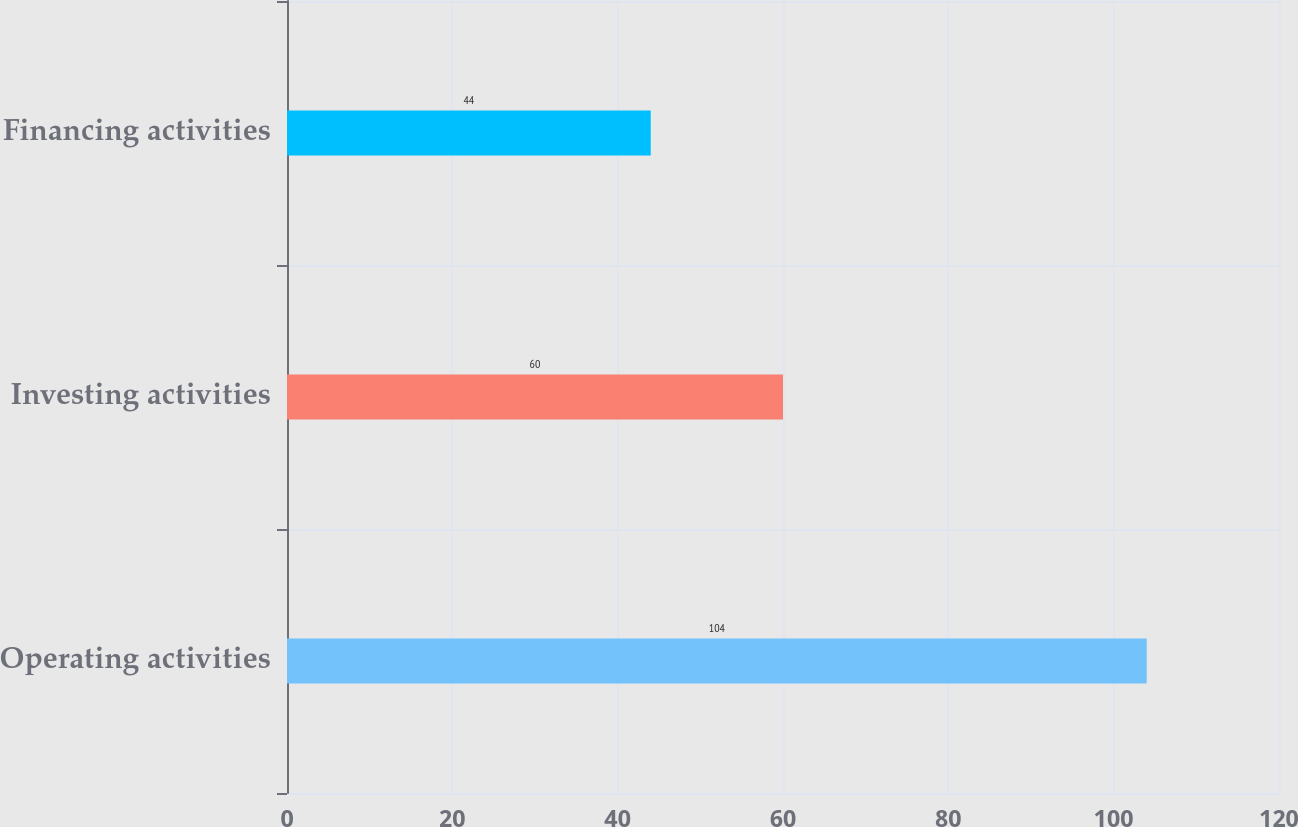Convert chart to OTSL. <chart><loc_0><loc_0><loc_500><loc_500><bar_chart><fcel>Operating activities<fcel>Investing activities<fcel>Financing activities<nl><fcel>104<fcel>60<fcel>44<nl></chart> 